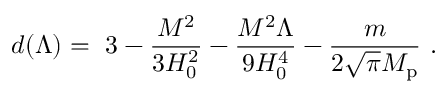Convert formula to latex. <formula><loc_0><loc_0><loc_500><loc_500>d ( \Lambda ) = \ 3 - { \frac { M ^ { 2 } } { 3 H _ { 0 } ^ { 2 } } } - { \frac { M ^ { 2 } \Lambda } { 9 H _ { 0 } ^ { 4 } } } - { \frac { m } { 2 \sqrt { \pi } M _ { p } } } \ .</formula> 